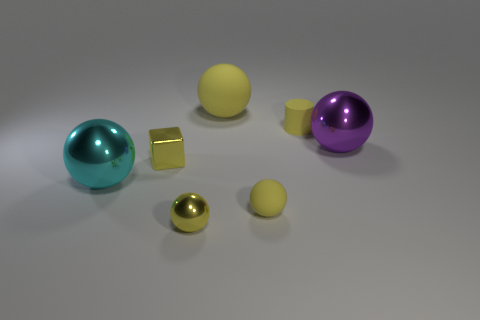Subtract all purple shiny balls. How many balls are left? 4 Add 2 cyan spheres. How many objects exist? 9 Subtract 1 spheres. How many spheres are left? 4 Subtract all purple spheres. How many spheres are left? 4 Subtract all purple cubes. How many yellow balls are left? 3 Subtract all cylinders. How many objects are left? 6 Subtract all yellow spheres. Subtract all green cylinders. How many spheres are left? 2 Subtract all red metal blocks. Subtract all big metal objects. How many objects are left? 5 Add 7 tiny metallic blocks. How many tiny metallic blocks are left? 8 Add 6 large things. How many large things exist? 9 